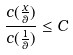Convert formula to latex. <formula><loc_0><loc_0><loc_500><loc_500>\frac { c ( \frac { x } { \theta } ) } { c ( \frac { 1 } { \theta } ) } \leq C</formula> 